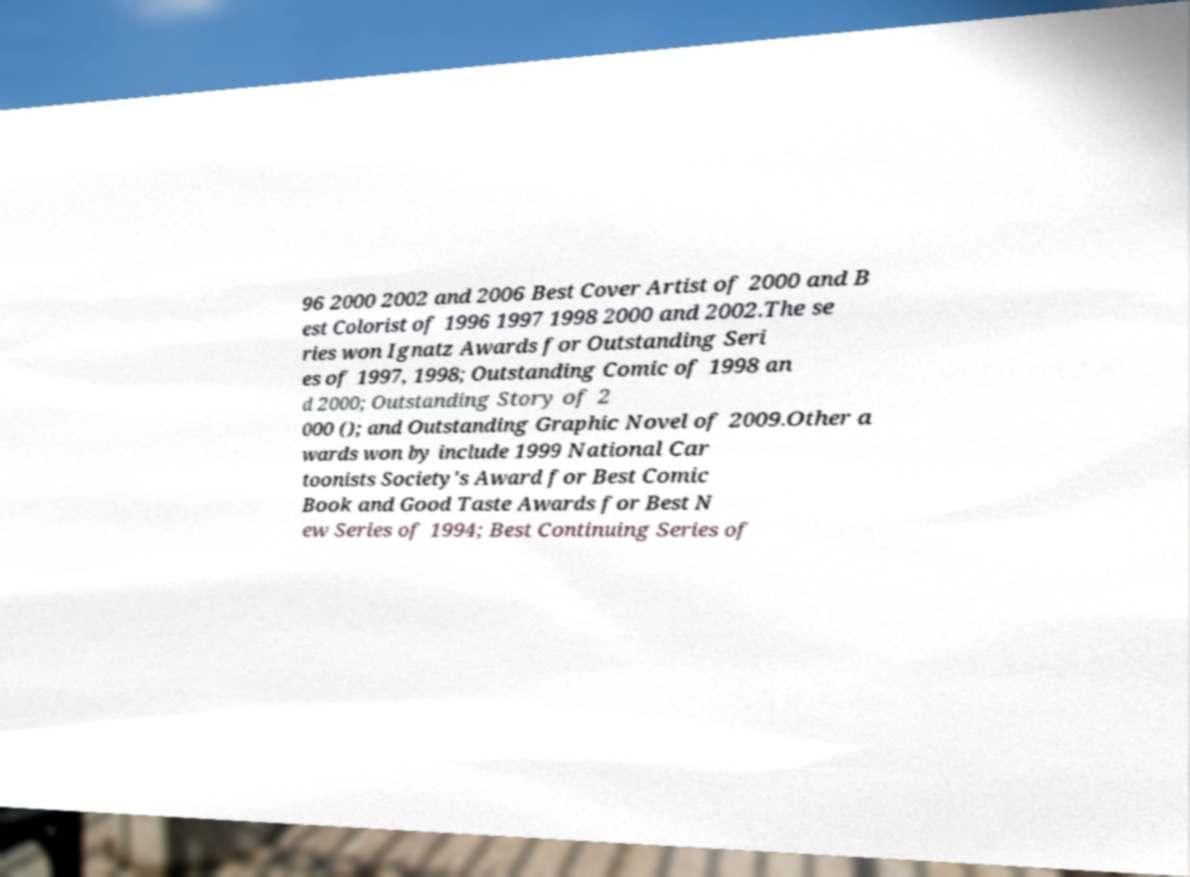Could you assist in decoding the text presented in this image and type it out clearly? 96 2000 2002 and 2006 Best Cover Artist of 2000 and B est Colorist of 1996 1997 1998 2000 and 2002.The se ries won Ignatz Awards for Outstanding Seri es of 1997, 1998; Outstanding Comic of 1998 an d 2000; Outstanding Story of 2 000 (); and Outstanding Graphic Novel of 2009.Other a wards won by include 1999 National Car toonists Society's Award for Best Comic Book and Good Taste Awards for Best N ew Series of 1994; Best Continuing Series of 